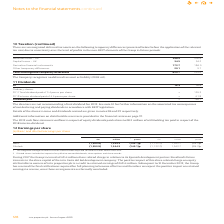According to Intu Properties's financial document, What is the revenue losses in UK in 2019? According to the financial document, 398.4 (in millions). The relevant text states: "Revenue losses – UK 398.4 300.8..." Also, What is the value of Derivative financial instruments in 2019? According to the financial document, 172.7 (in millions). The relevant text states: "Derivative financial instruments 172.7 184.9..." Also, What is the amount of capital losses in UK in 2019? According to the financial document, 34.5 (in millions). The relevant text states: "Capital losses – UK 34.5 34.2..." Also, can you calculate: What is the percentage change in the revenue losses in UK from 2018 to 2019? To answer this question, I need to perform calculations using the financial data. The calculation is: (398.4-300.8)/300.8, which equals 32.45 (percentage). This is based on the information: "Revenue losses – UK 398.4 300.8 Revenue losses – UK 398.4 300.8..." The key data points involved are: 300.8, 398.4. Also, can you calculate: What is the change in capital losses from the UK between 2018 and 2019? Based on the calculation: 34.5-34.2, the result is 0.3 (in millions). This is based on the information: "Capital losses – UK 34.5 34.2 Capital losses – UK 34.5 34.2..." The key data points involved are: 34.2, 34.5. Also, can you calculate: What is the percentage change in the total unrecognised temporary differences from 2018 to 2019? To answer this question, I need to perform calculations using the financial data. The calculation is: (625.7-529.6)/529.6, which equals 18.15 (percentage). This is based on the information: "Total unrecognised temporary differences 625.7 529.6 Total unrecognised temporary differences 625.7 529.6..." The key data points involved are: 529.6, 625.7. 